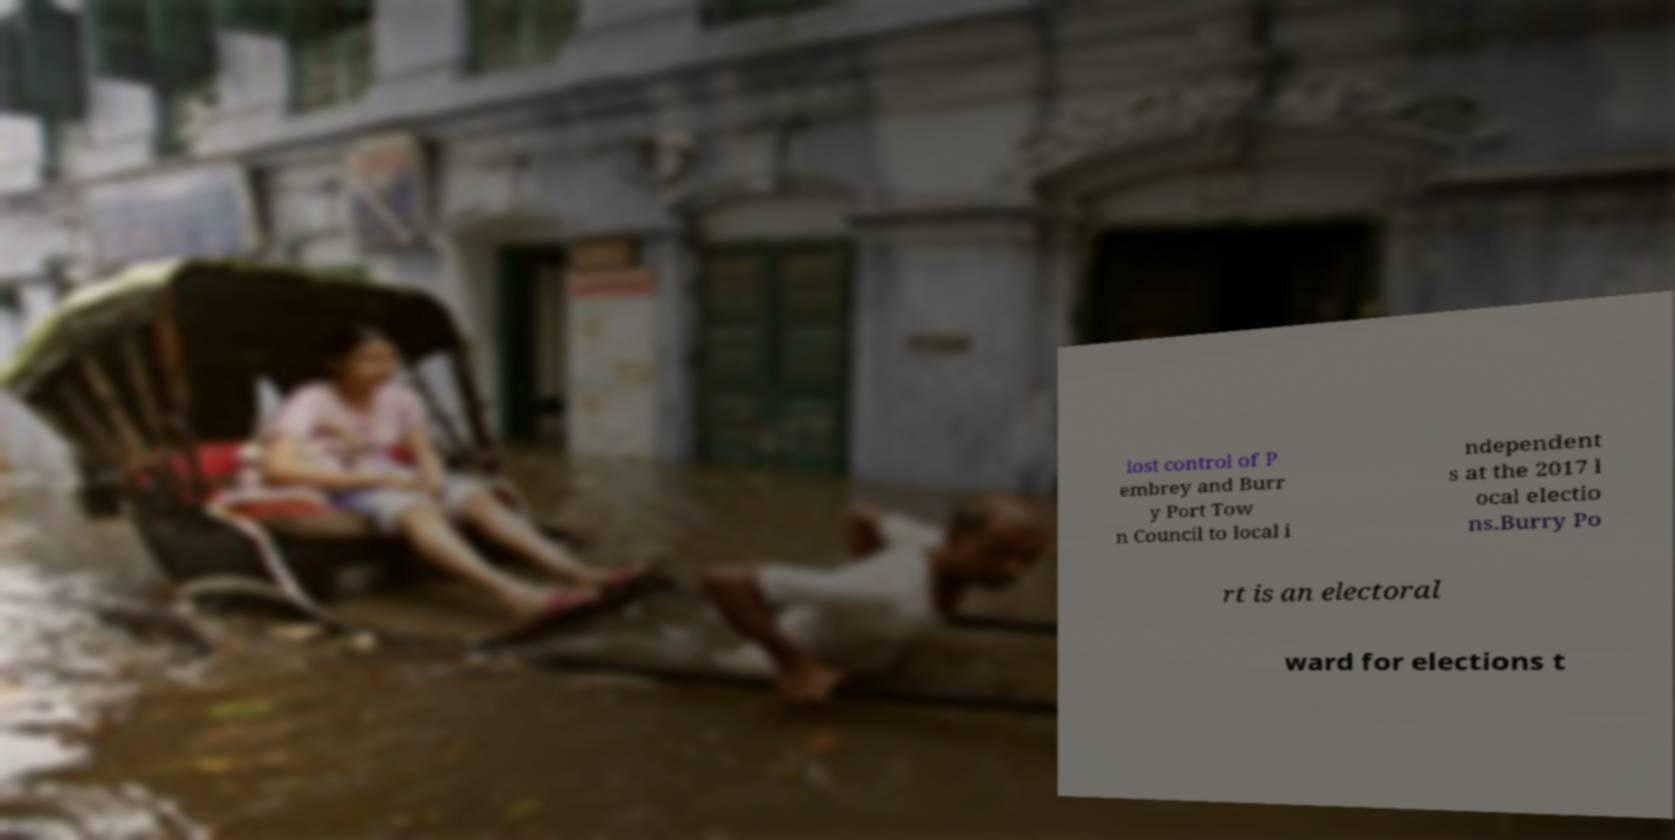Could you extract and type out the text from this image? lost control of P embrey and Burr y Port Tow n Council to local i ndependent s at the 2017 l ocal electio ns.Burry Po rt is an electoral ward for elections t 